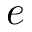<formula> <loc_0><loc_0><loc_500><loc_500>e</formula> 